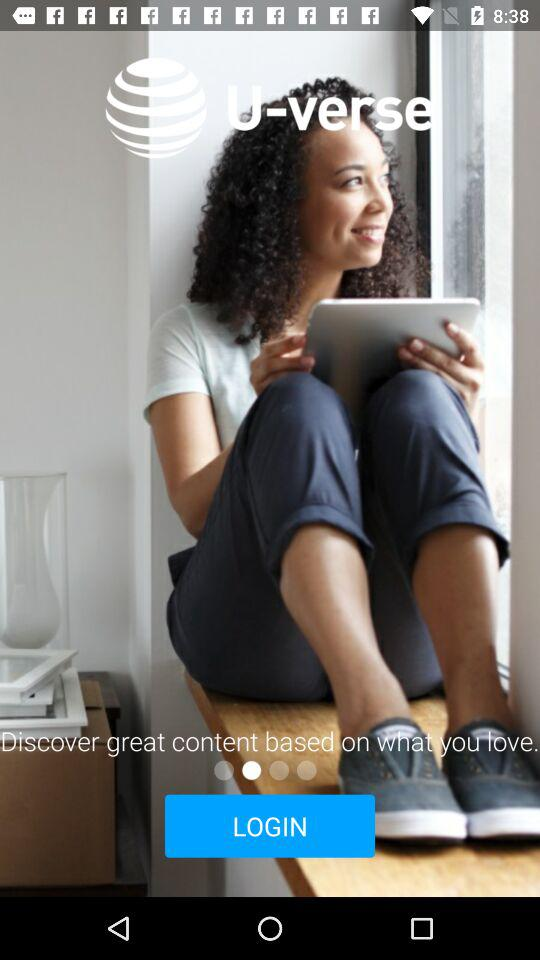What is the name of the application? The name of the application is "AT&T U-verse". 